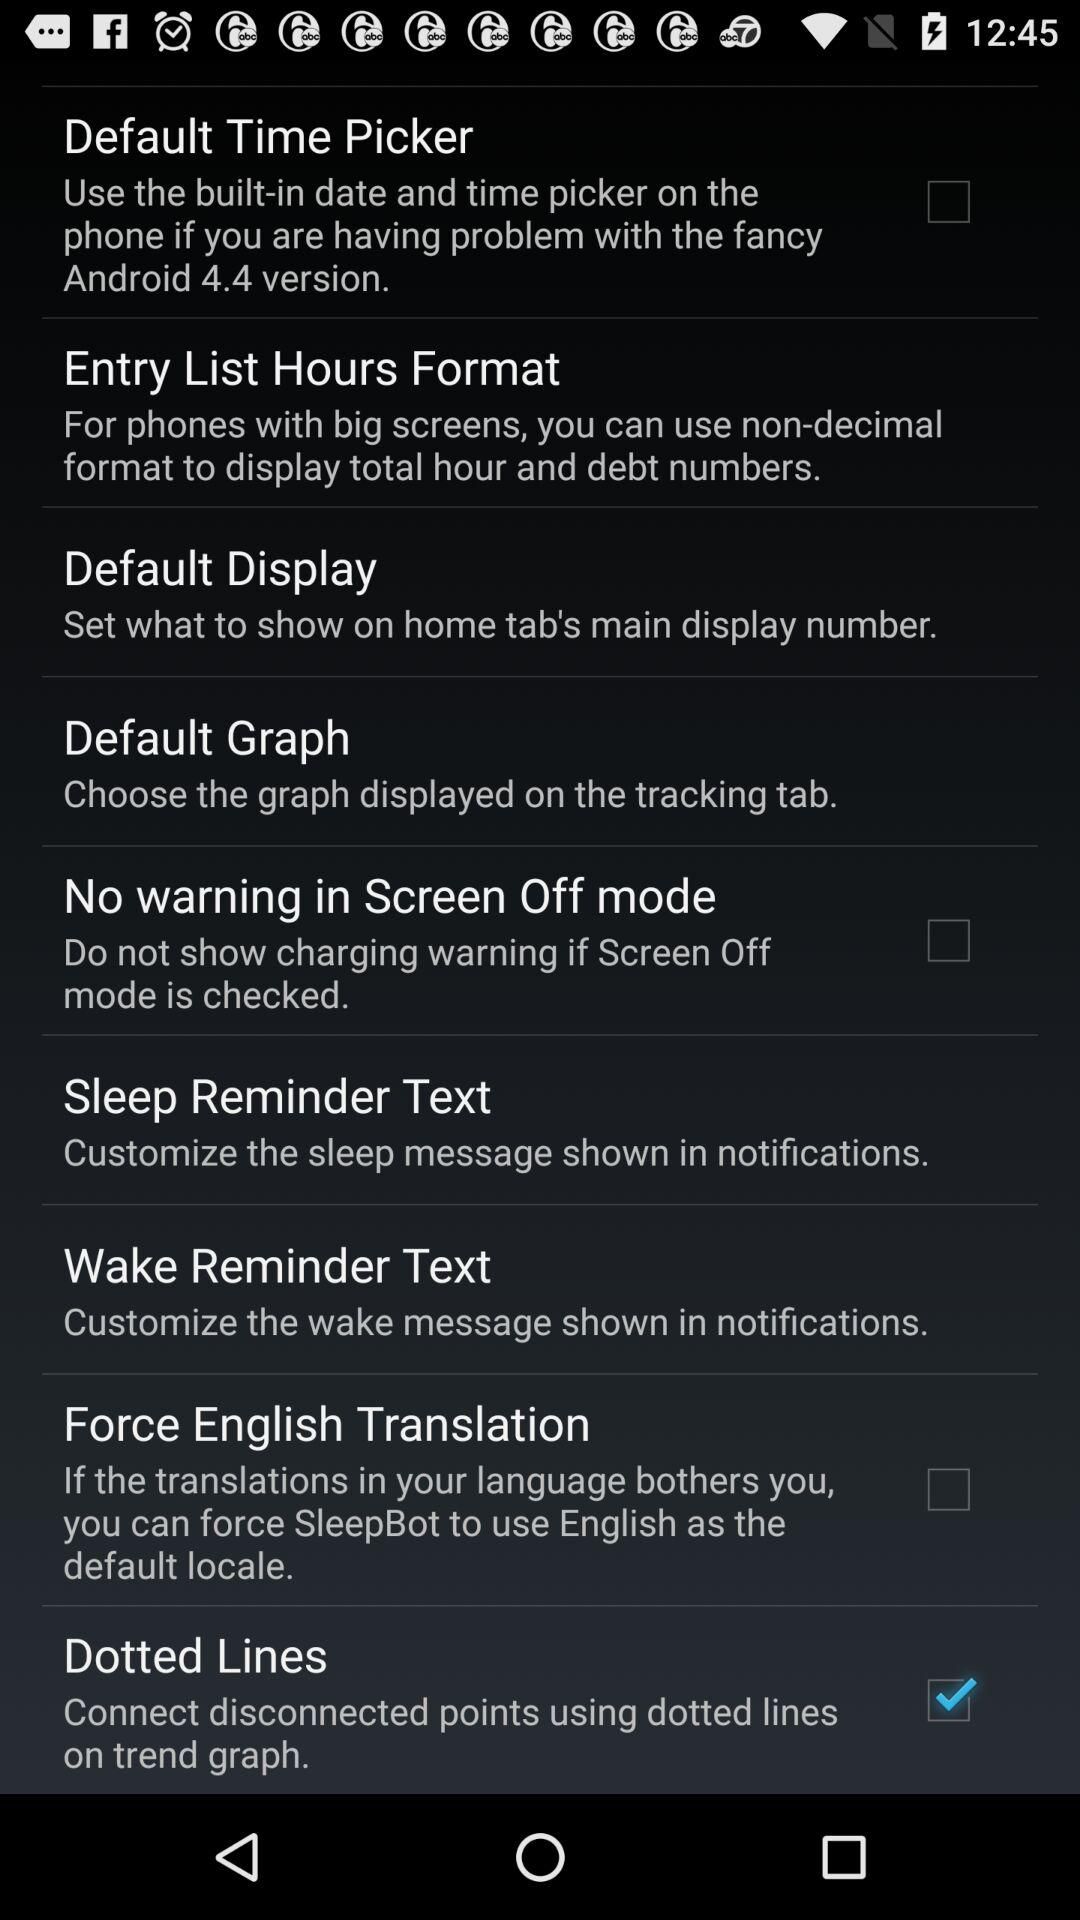What is the status of "No warning in Screen Off mode"? The status is "off". 